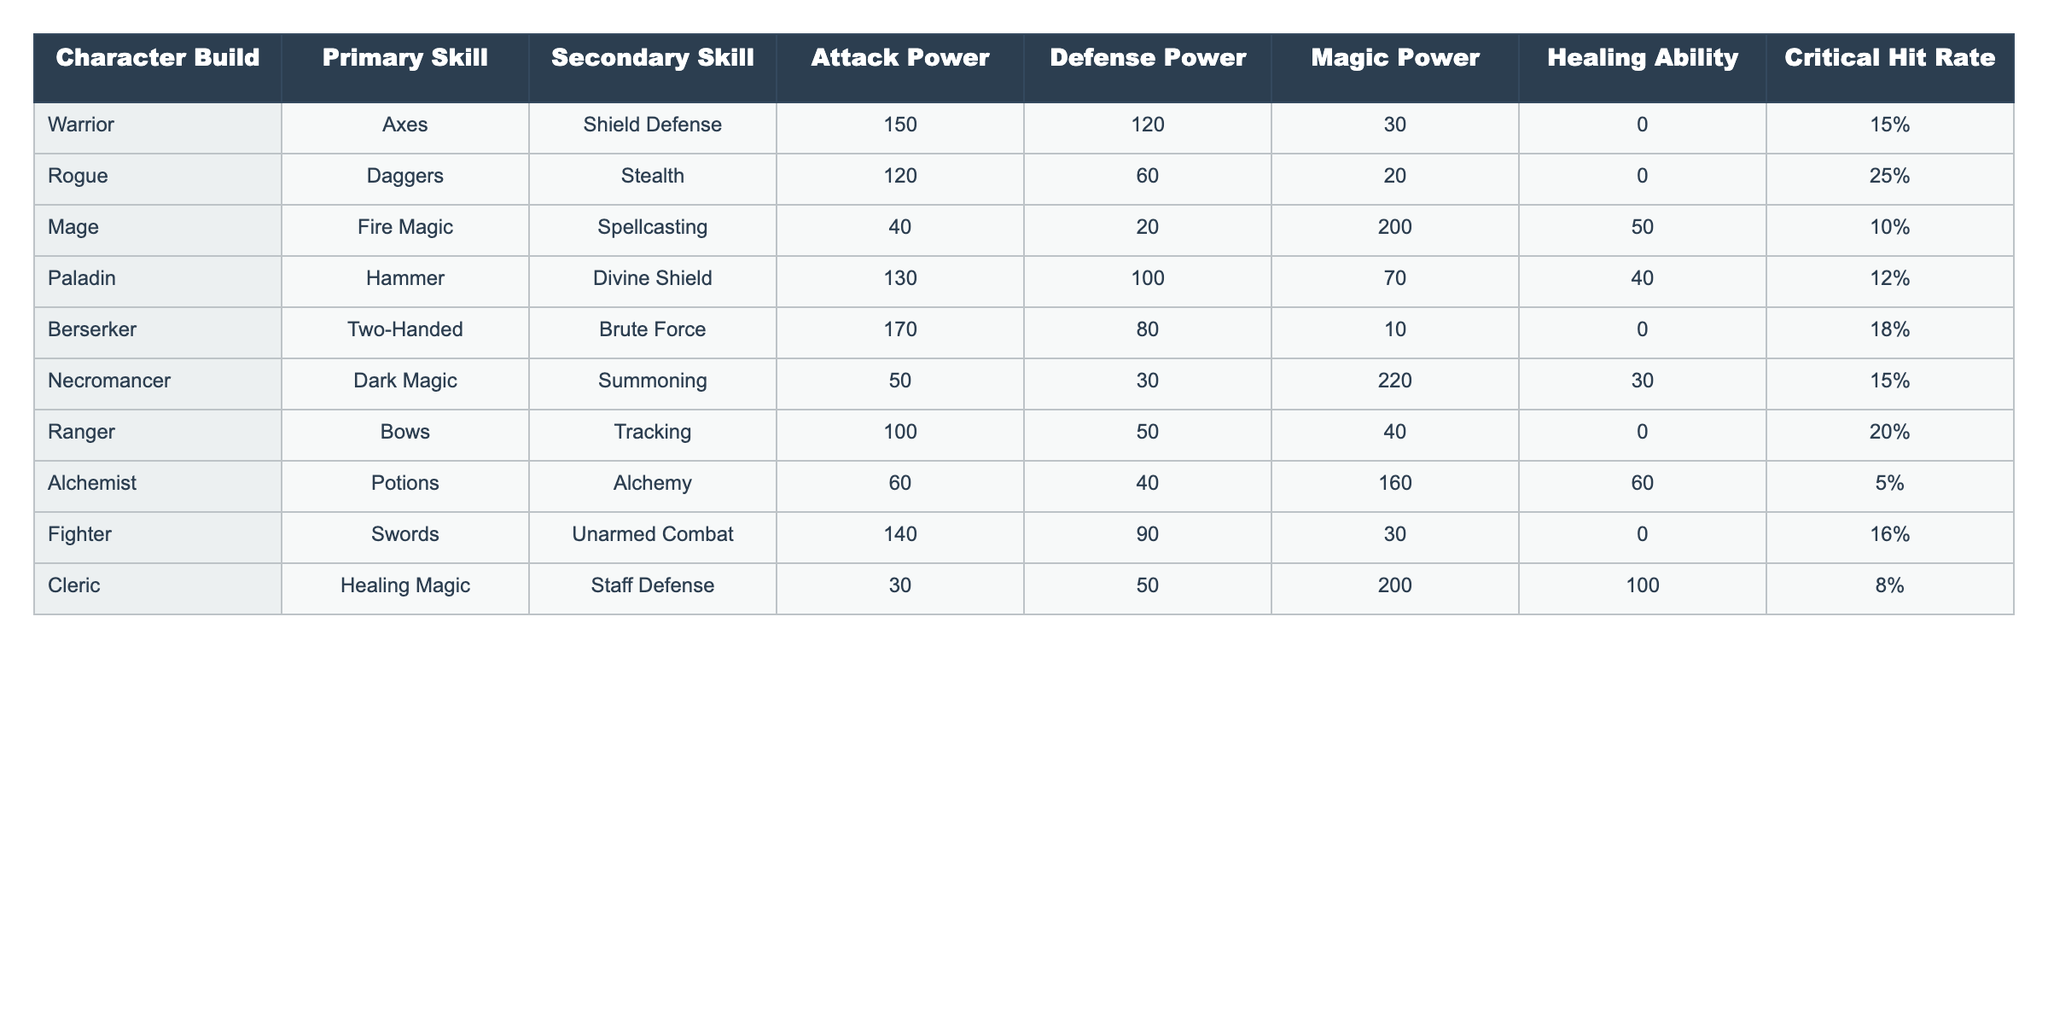What is the primary skill of the Necromancer? The table clearly shows the skills for each character build. For the Necromancer, the primary skill is listed under the "Primary Skill" column.
Answer: Dark Magic Which character build has the highest Attack Power? By examining the "Attack Power" column, we see that the Berserker has the highest value at 170.
Answer: Berserker What is the average Defense Power of all character builds? To find the average Defense Power, we sum all the values in the "Defense Power" column (120 + 60 + 20 + 100 + 80 + 30 + 50 + 40 + 90 + 50 = 600) and divide by the number of builds (10). So, 600/10 = 60.
Answer: 60 Do Rogues have a higher Critical Hit Rate than Mages? Checking the "Critical Hit Rate" column reveals that Rogues have a rate of 25% while Mages have a rate of 10%. Since 25% is greater than 10%, the answer is yes.
Answer: Yes What is the total Healing Ability of the Paladin and Cleric combined? The Healing Ability for the Paladin is 40 and for the Cleric it's 100. Adding these two values together gives 40 + 100 = 140.
Answer: 140 Which character builds have a Magic Power greater than 100? Looking at the "Magic Power" column, the Mage has 200, the Necromancer has 220, and the Alchemist has 160, all greater than 100. Therefore, the character builds are Mage, Necromancer, and Alchemist.
Answer: Mage, Necromancer, Alchemist Is the Defense Power of the Fighter greater than that of the Ranger? The "Defense Power" for the Fighter is 90, and for the Ranger, it is 50. Since 90 is greater than 50, the answer is yes.
Answer: Yes What character build has the highest Magic Power and what is that value? By checking the "Magic Power" column, we find that the Necromancer has the highest Magic Power at 220.
Answer: Necromancer, 220 What is the difference in Attack Power between the Berserker and the Warrior? The Attack Power for the Berserker is 170 and for the Warrior is 150. The difference is calculated as 170 - 150 = 20.
Answer: 20 Are there any character builds with Healing Ability greater than 50? Checking the "Healing Ability" column, we find the Paladin (40) and the Cleric (100). The Cleric has a Healing Ability greater than 50, so the answer is yes.
Answer: Yes 